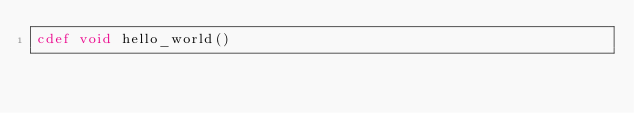<code> <loc_0><loc_0><loc_500><loc_500><_Cython_>cdef void hello_world()
</code> 